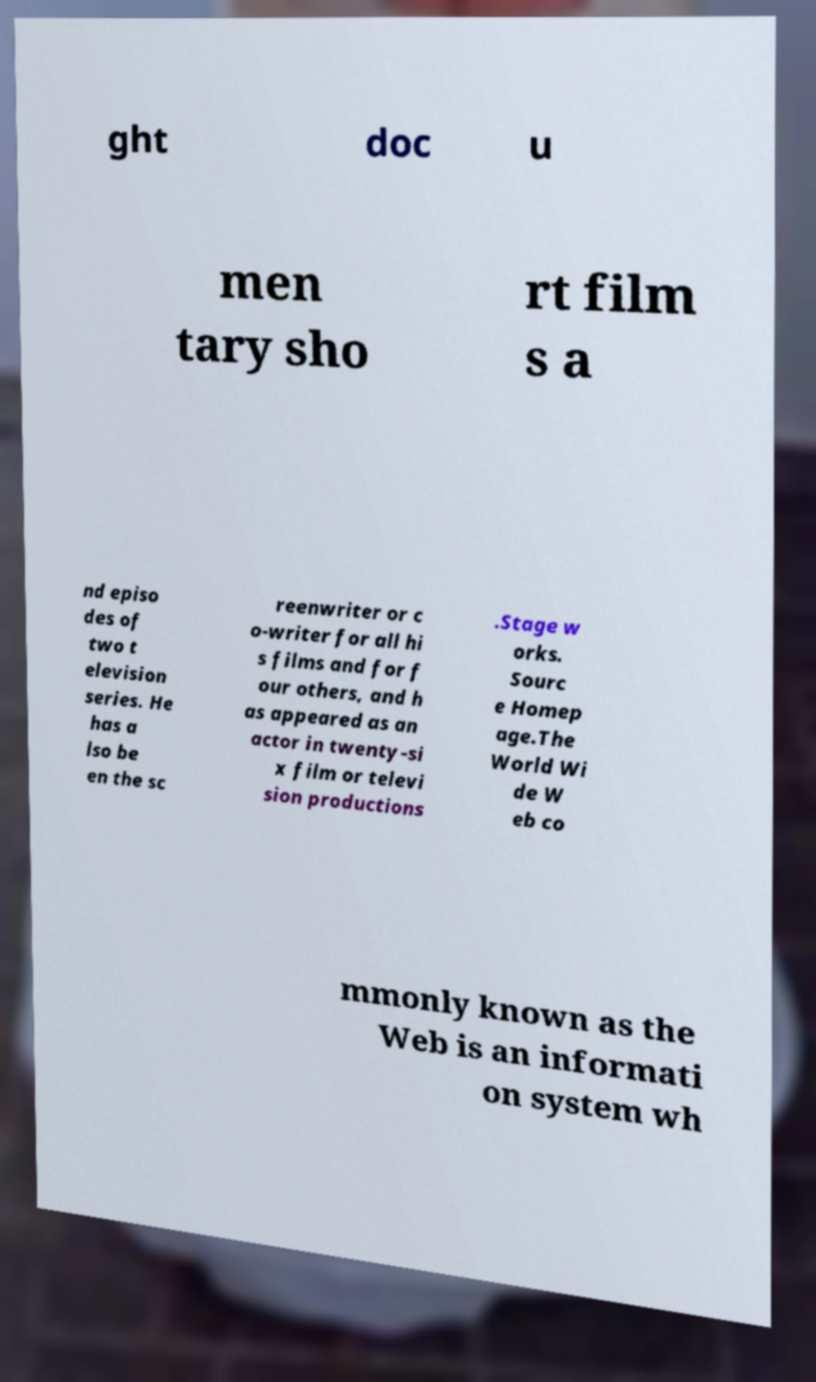Can you accurately transcribe the text from the provided image for me? ght doc u men tary sho rt film s a nd episo des of two t elevision series. He has a lso be en the sc reenwriter or c o-writer for all hi s films and for f our others, and h as appeared as an actor in twenty-si x film or televi sion productions .Stage w orks. Sourc e Homep age.The World Wi de W eb co mmonly known as the Web is an informati on system wh 